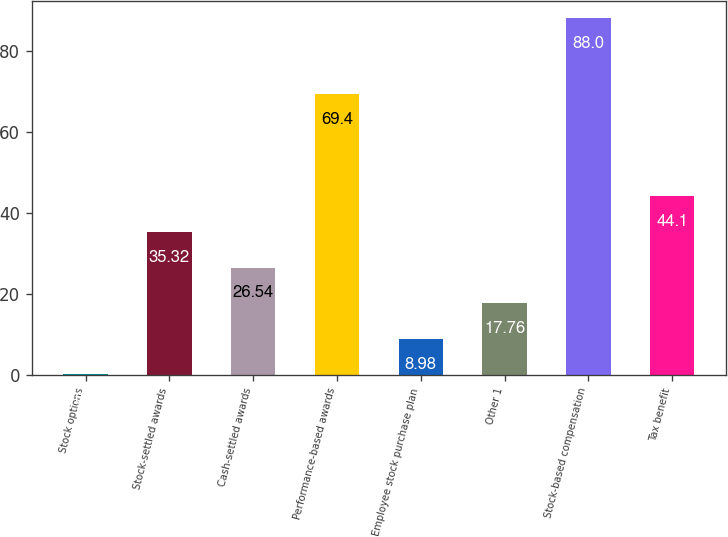Convert chart to OTSL. <chart><loc_0><loc_0><loc_500><loc_500><bar_chart><fcel>Stock options<fcel>Stock-settled awards<fcel>Cash-settled awards<fcel>Performance-based awards<fcel>Employee stock purchase plan<fcel>Other 1<fcel>Stock-based compensation<fcel>Tax benefit<nl><fcel>0.2<fcel>35.32<fcel>26.54<fcel>69.4<fcel>8.98<fcel>17.76<fcel>88<fcel>44.1<nl></chart> 